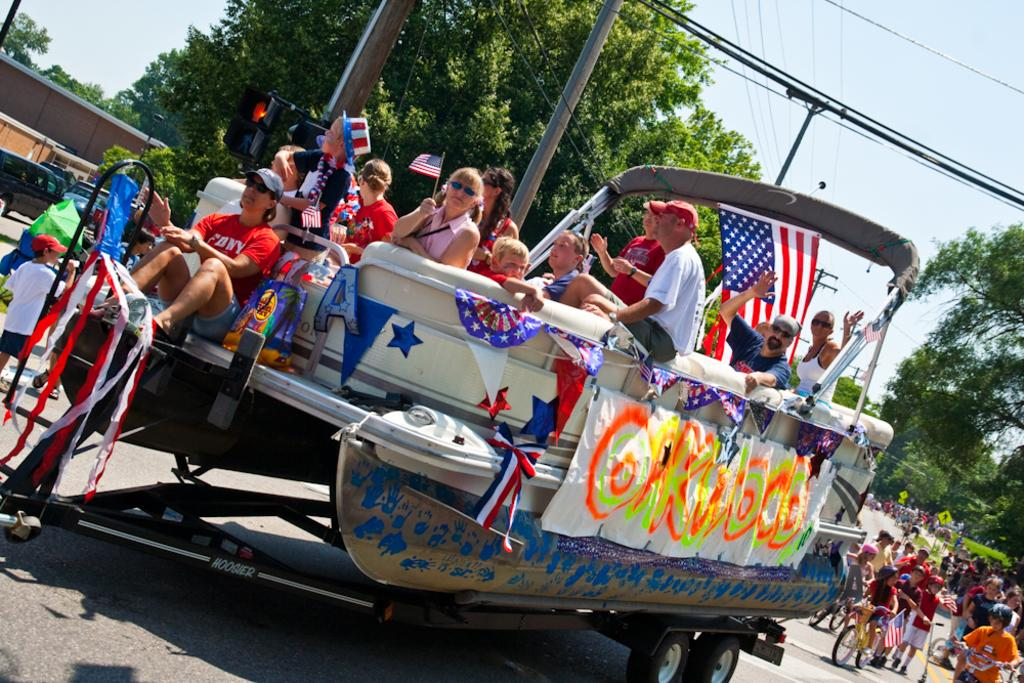Provide a one-sentence caption for the provided image. A decorated boat on a tow for a parade, with a spray-painted sign on the side reading OAKWOOD. 